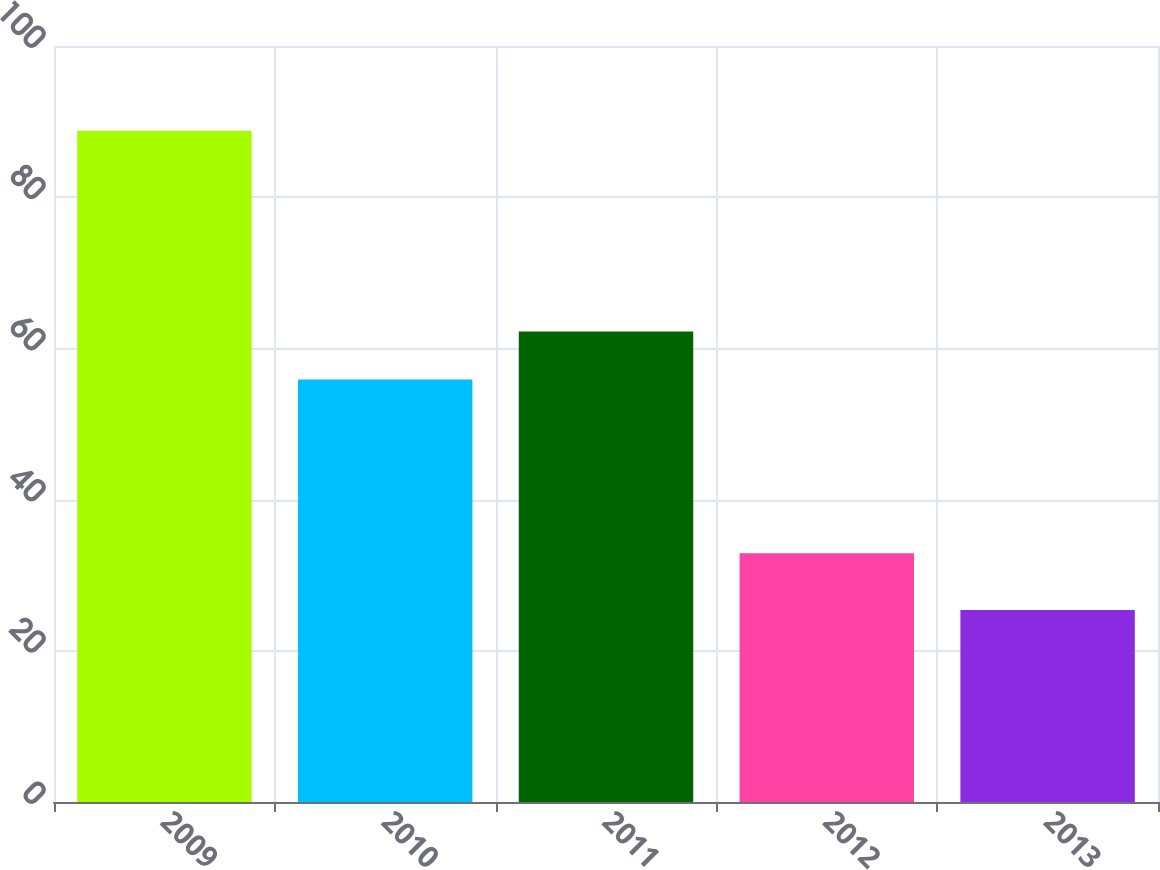Convert chart. <chart><loc_0><loc_0><loc_500><loc_500><bar_chart><fcel>2009<fcel>2010<fcel>2011<fcel>2012<fcel>2013<nl><fcel>88.8<fcel>55.9<fcel>62.24<fcel>32.9<fcel>25.4<nl></chart> 